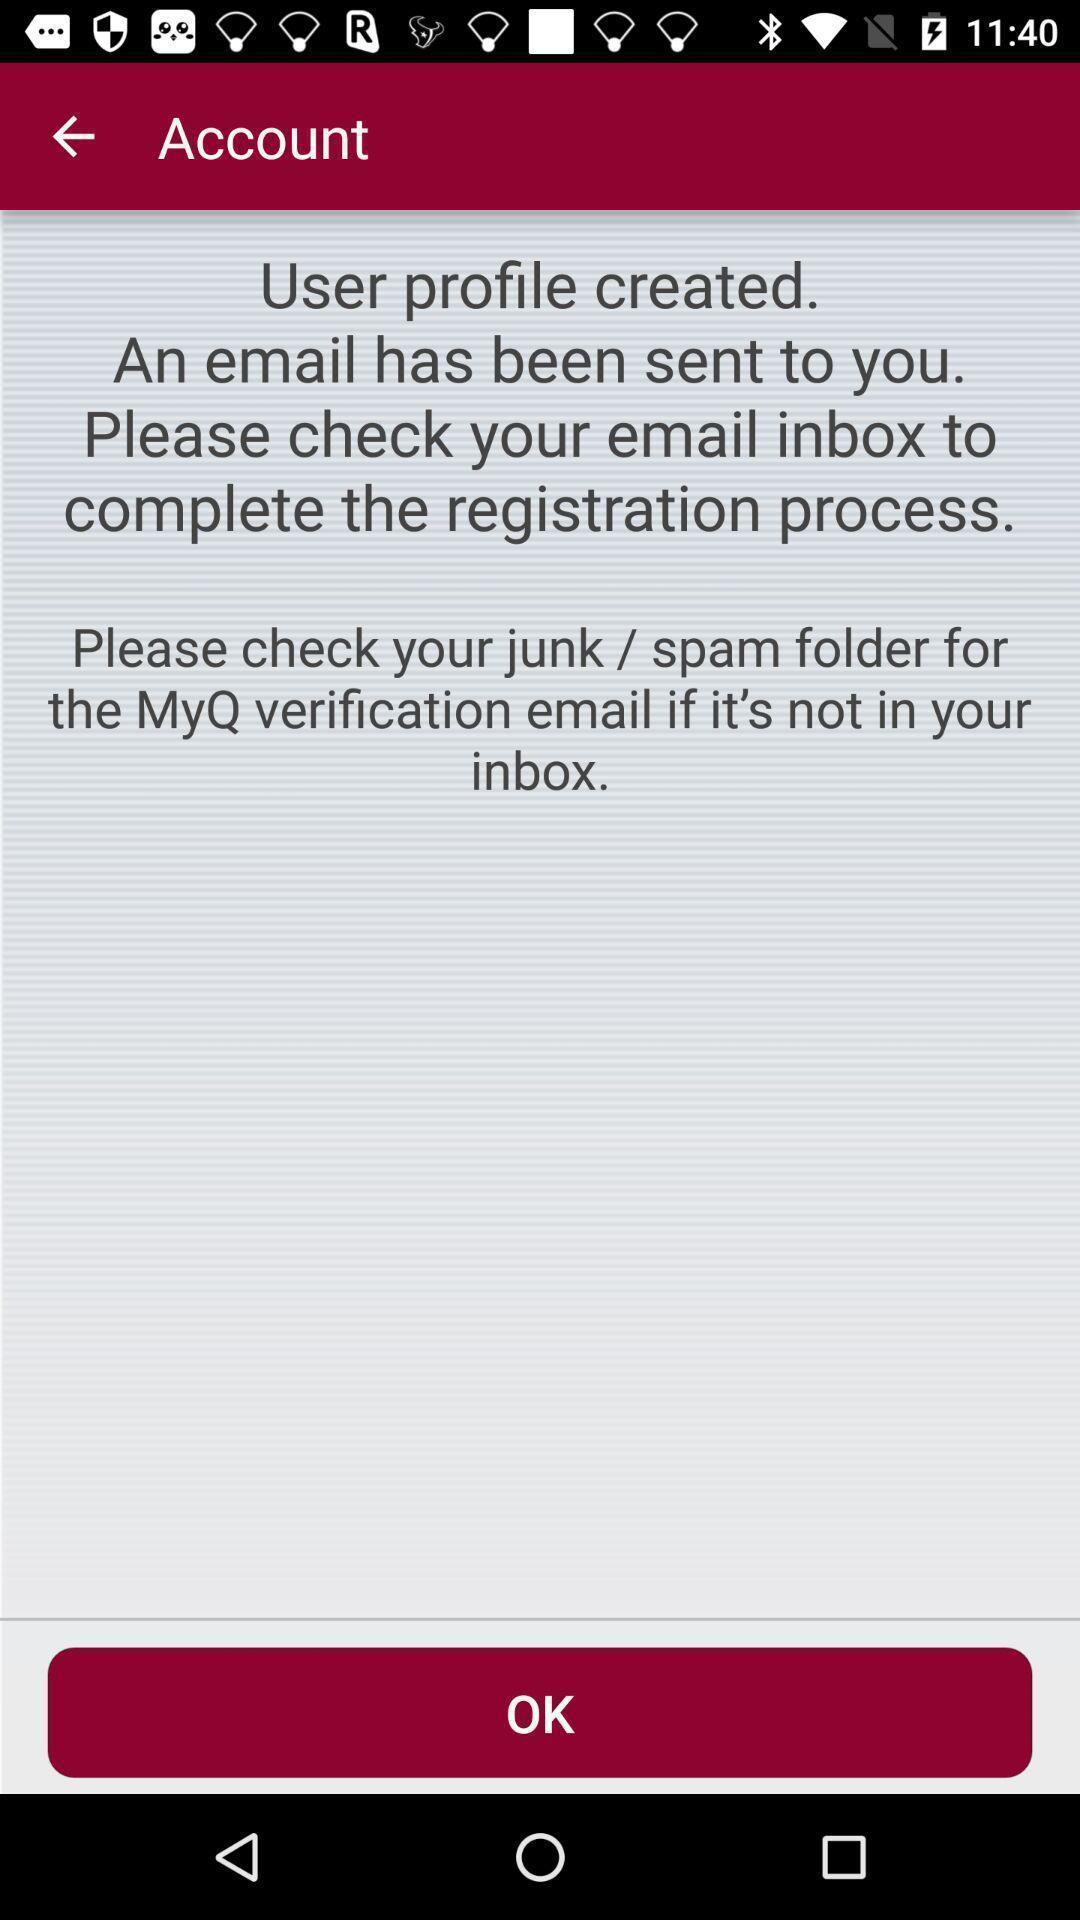What is the overall content of this screenshot? Page showing information about account. 